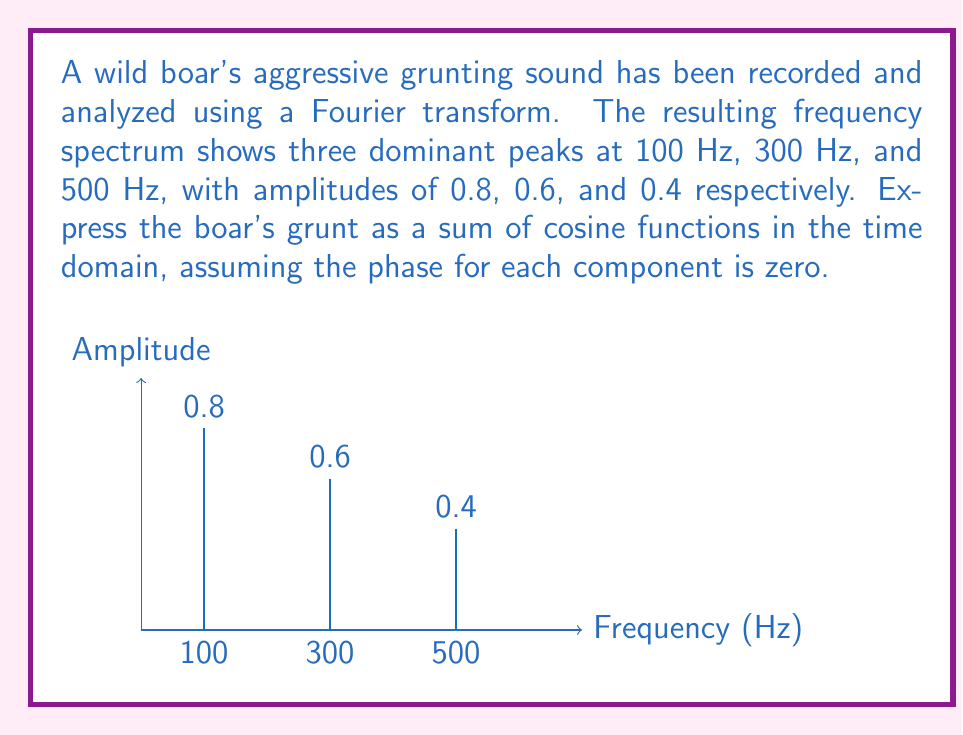Teach me how to tackle this problem. To express the boar's grunt as a sum of cosine functions, we need to use the general form of a Fourier series:

$$ x(t) = \sum_{n=1}^{N} A_n \cos(2\pi f_n t + \phi_n) $$

Where:
- $A_n$ is the amplitude of each component
- $f_n$ is the frequency of each component
- $\phi_n$ is the phase of each component (given as zero in this case)
- $t$ is time

We have three components, so N = 3. Let's substitute the given values:

1. First component: $A_1 = 0.8$, $f_1 = 100$ Hz
2. Second component: $A_2 = 0.6$, $f_2 = 300$ Hz
3. Third component: $A_3 = 0.4$, $f_3 = 500$ Hz

Substituting these values into the equation:

$$ x(t) = 0.8 \cos(2\pi \cdot 100t) + 0.6 \cos(2\pi \cdot 300t) + 0.4 \cos(2\pi \cdot 500t) $$

This equation represents the boar's grunt as a sum of cosine functions in the time domain.
Answer: $x(t) = 0.8 \cos(200\pi t) + 0.6 \cos(600\pi t) + 0.4 \cos(1000\pi t)$ 